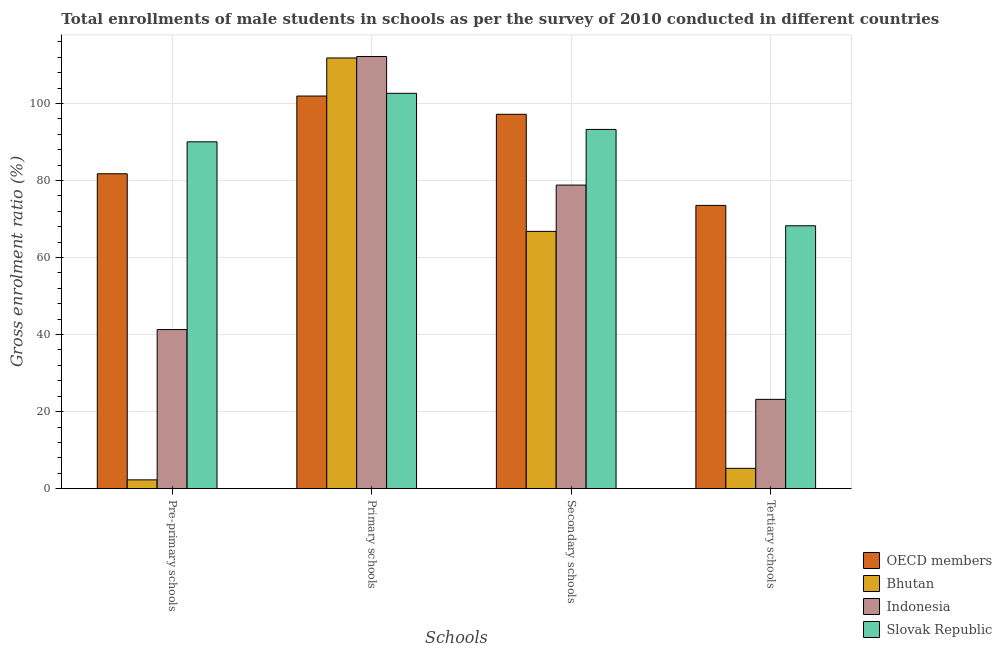Are the number of bars per tick equal to the number of legend labels?
Your answer should be compact. Yes. How many bars are there on the 2nd tick from the right?
Your response must be concise. 4. What is the label of the 3rd group of bars from the left?
Make the answer very short. Secondary schools. What is the gross enrolment ratio(male) in secondary schools in Slovak Republic?
Your answer should be very brief. 93.25. Across all countries, what is the maximum gross enrolment ratio(male) in primary schools?
Offer a very short reply. 112.19. Across all countries, what is the minimum gross enrolment ratio(male) in secondary schools?
Provide a succinct answer. 66.79. In which country was the gross enrolment ratio(male) in pre-primary schools maximum?
Provide a short and direct response. Slovak Republic. In which country was the gross enrolment ratio(male) in tertiary schools minimum?
Your answer should be compact. Bhutan. What is the total gross enrolment ratio(male) in pre-primary schools in the graph?
Offer a very short reply. 215.37. What is the difference between the gross enrolment ratio(male) in pre-primary schools in Bhutan and that in OECD members?
Ensure brevity in your answer.  -79.45. What is the difference between the gross enrolment ratio(male) in tertiary schools in Bhutan and the gross enrolment ratio(male) in pre-primary schools in OECD members?
Your response must be concise. -76.46. What is the average gross enrolment ratio(male) in pre-primary schools per country?
Your response must be concise. 53.84. What is the difference between the gross enrolment ratio(male) in secondary schools and gross enrolment ratio(male) in pre-primary schools in OECD members?
Offer a terse response. 15.44. In how many countries, is the gross enrolment ratio(male) in primary schools greater than 60 %?
Offer a very short reply. 4. What is the ratio of the gross enrolment ratio(male) in secondary schools in Bhutan to that in OECD members?
Your response must be concise. 0.69. Is the gross enrolment ratio(male) in secondary schools in OECD members less than that in Slovak Republic?
Your answer should be very brief. No. What is the difference between the highest and the second highest gross enrolment ratio(male) in primary schools?
Provide a succinct answer. 0.38. What is the difference between the highest and the lowest gross enrolment ratio(male) in tertiary schools?
Make the answer very short. 68.25. What does the 3rd bar from the right in Pre-primary schools represents?
Your answer should be compact. Bhutan. Is it the case that in every country, the sum of the gross enrolment ratio(male) in pre-primary schools and gross enrolment ratio(male) in primary schools is greater than the gross enrolment ratio(male) in secondary schools?
Offer a terse response. Yes. Does the graph contain grids?
Ensure brevity in your answer.  Yes. How many legend labels are there?
Provide a succinct answer. 4. What is the title of the graph?
Offer a very short reply. Total enrollments of male students in schools as per the survey of 2010 conducted in different countries. Does "Nigeria" appear as one of the legend labels in the graph?
Give a very brief answer. No. What is the label or title of the X-axis?
Offer a terse response. Schools. What is the Gross enrolment ratio (%) in OECD members in Pre-primary schools?
Your response must be concise. 81.74. What is the Gross enrolment ratio (%) in Bhutan in Pre-primary schools?
Ensure brevity in your answer.  2.29. What is the Gross enrolment ratio (%) of Indonesia in Pre-primary schools?
Your response must be concise. 41.3. What is the Gross enrolment ratio (%) in Slovak Republic in Pre-primary schools?
Offer a very short reply. 90.04. What is the Gross enrolment ratio (%) in OECD members in Primary schools?
Your answer should be compact. 101.92. What is the Gross enrolment ratio (%) of Bhutan in Primary schools?
Offer a very short reply. 111.8. What is the Gross enrolment ratio (%) of Indonesia in Primary schools?
Give a very brief answer. 112.19. What is the Gross enrolment ratio (%) of Slovak Republic in Primary schools?
Offer a terse response. 102.63. What is the Gross enrolment ratio (%) in OECD members in Secondary schools?
Ensure brevity in your answer.  97.18. What is the Gross enrolment ratio (%) of Bhutan in Secondary schools?
Your answer should be compact. 66.79. What is the Gross enrolment ratio (%) in Indonesia in Secondary schools?
Keep it short and to the point. 78.8. What is the Gross enrolment ratio (%) in Slovak Republic in Secondary schools?
Keep it short and to the point. 93.25. What is the Gross enrolment ratio (%) in OECD members in Tertiary schools?
Offer a very short reply. 73.53. What is the Gross enrolment ratio (%) in Bhutan in Tertiary schools?
Your response must be concise. 5.28. What is the Gross enrolment ratio (%) in Indonesia in Tertiary schools?
Keep it short and to the point. 23.19. What is the Gross enrolment ratio (%) in Slovak Republic in Tertiary schools?
Provide a succinct answer. 68.24. Across all Schools, what is the maximum Gross enrolment ratio (%) of OECD members?
Keep it short and to the point. 101.92. Across all Schools, what is the maximum Gross enrolment ratio (%) of Bhutan?
Ensure brevity in your answer.  111.8. Across all Schools, what is the maximum Gross enrolment ratio (%) in Indonesia?
Ensure brevity in your answer.  112.19. Across all Schools, what is the maximum Gross enrolment ratio (%) in Slovak Republic?
Ensure brevity in your answer.  102.63. Across all Schools, what is the minimum Gross enrolment ratio (%) in OECD members?
Your response must be concise. 73.53. Across all Schools, what is the minimum Gross enrolment ratio (%) in Bhutan?
Your response must be concise. 2.29. Across all Schools, what is the minimum Gross enrolment ratio (%) in Indonesia?
Offer a terse response. 23.19. Across all Schools, what is the minimum Gross enrolment ratio (%) of Slovak Republic?
Keep it short and to the point. 68.24. What is the total Gross enrolment ratio (%) of OECD members in the graph?
Give a very brief answer. 354.37. What is the total Gross enrolment ratio (%) of Bhutan in the graph?
Offer a very short reply. 186.16. What is the total Gross enrolment ratio (%) of Indonesia in the graph?
Provide a short and direct response. 255.48. What is the total Gross enrolment ratio (%) of Slovak Republic in the graph?
Your answer should be compact. 354.15. What is the difference between the Gross enrolment ratio (%) of OECD members in Pre-primary schools and that in Primary schools?
Ensure brevity in your answer.  -20.18. What is the difference between the Gross enrolment ratio (%) of Bhutan in Pre-primary schools and that in Primary schools?
Your answer should be very brief. -109.51. What is the difference between the Gross enrolment ratio (%) of Indonesia in Pre-primary schools and that in Primary schools?
Provide a succinct answer. -70.88. What is the difference between the Gross enrolment ratio (%) in Slovak Republic in Pre-primary schools and that in Primary schools?
Your answer should be very brief. -12.59. What is the difference between the Gross enrolment ratio (%) in OECD members in Pre-primary schools and that in Secondary schools?
Your answer should be very brief. -15.44. What is the difference between the Gross enrolment ratio (%) in Bhutan in Pre-primary schools and that in Secondary schools?
Give a very brief answer. -64.5. What is the difference between the Gross enrolment ratio (%) of Indonesia in Pre-primary schools and that in Secondary schools?
Keep it short and to the point. -37.5. What is the difference between the Gross enrolment ratio (%) of Slovak Republic in Pre-primary schools and that in Secondary schools?
Offer a very short reply. -3.21. What is the difference between the Gross enrolment ratio (%) of OECD members in Pre-primary schools and that in Tertiary schools?
Your answer should be very brief. 8.21. What is the difference between the Gross enrolment ratio (%) of Bhutan in Pre-primary schools and that in Tertiary schools?
Ensure brevity in your answer.  -2.99. What is the difference between the Gross enrolment ratio (%) of Indonesia in Pre-primary schools and that in Tertiary schools?
Make the answer very short. 18.12. What is the difference between the Gross enrolment ratio (%) in Slovak Republic in Pre-primary schools and that in Tertiary schools?
Your response must be concise. 21.79. What is the difference between the Gross enrolment ratio (%) of OECD members in Primary schools and that in Secondary schools?
Offer a very short reply. 4.73. What is the difference between the Gross enrolment ratio (%) in Bhutan in Primary schools and that in Secondary schools?
Offer a very short reply. 45.01. What is the difference between the Gross enrolment ratio (%) of Indonesia in Primary schools and that in Secondary schools?
Ensure brevity in your answer.  33.38. What is the difference between the Gross enrolment ratio (%) of Slovak Republic in Primary schools and that in Secondary schools?
Give a very brief answer. 9.38. What is the difference between the Gross enrolment ratio (%) of OECD members in Primary schools and that in Tertiary schools?
Your answer should be compact. 28.39. What is the difference between the Gross enrolment ratio (%) in Bhutan in Primary schools and that in Tertiary schools?
Offer a terse response. 106.52. What is the difference between the Gross enrolment ratio (%) of Indonesia in Primary schools and that in Tertiary schools?
Your answer should be very brief. 89. What is the difference between the Gross enrolment ratio (%) in Slovak Republic in Primary schools and that in Tertiary schools?
Your answer should be very brief. 34.38. What is the difference between the Gross enrolment ratio (%) of OECD members in Secondary schools and that in Tertiary schools?
Keep it short and to the point. 23.65. What is the difference between the Gross enrolment ratio (%) in Bhutan in Secondary schools and that in Tertiary schools?
Give a very brief answer. 61.51. What is the difference between the Gross enrolment ratio (%) of Indonesia in Secondary schools and that in Tertiary schools?
Ensure brevity in your answer.  55.62. What is the difference between the Gross enrolment ratio (%) of Slovak Republic in Secondary schools and that in Tertiary schools?
Your answer should be very brief. 25.01. What is the difference between the Gross enrolment ratio (%) in OECD members in Pre-primary schools and the Gross enrolment ratio (%) in Bhutan in Primary schools?
Your answer should be very brief. -30.06. What is the difference between the Gross enrolment ratio (%) in OECD members in Pre-primary schools and the Gross enrolment ratio (%) in Indonesia in Primary schools?
Offer a very short reply. -30.45. What is the difference between the Gross enrolment ratio (%) in OECD members in Pre-primary schools and the Gross enrolment ratio (%) in Slovak Republic in Primary schools?
Your answer should be very brief. -20.89. What is the difference between the Gross enrolment ratio (%) in Bhutan in Pre-primary schools and the Gross enrolment ratio (%) in Indonesia in Primary schools?
Your response must be concise. -109.89. What is the difference between the Gross enrolment ratio (%) of Bhutan in Pre-primary schools and the Gross enrolment ratio (%) of Slovak Republic in Primary schools?
Your answer should be very brief. -100.33. What is the difference between the Gross enrolment ratio (%) in Indonesia in Pre-primary schools and the Gross enrolment ratio (%) in Slovak Republic in Primary schools?
Your answer should be compact. -61.32. What is the difference between the Gross enrolment ratio (%) of OECD members in Pre-primary schools and the Gross enrolment ratio (%) of Bhutan in Secondary schools?
Your answer should be compact. 14.95. What is the difference between the Gross enrolment ratio (%) of OECD members in Pre-primary schools and the Gross enrolment ratio (%) of Indonesia in Secondary schools?
Ensure brevity in your answer.  2.93. What is the difference between the Gross enrolment ratio (%) of OECD members in Pre-primary schools and the Gross enrolment ratio (%) of Slovak Republic in Secondary schools?
Offer a terse response. -11.51. What is the difference between the Gross enrolment ratio (%) in Bhutan in Pre-primary schools and the Gross enrolment ratio (%) in Indonesia in Secondary schools?
Give a very brief answer. -76.51. What is the difference between the Gross enrolment ratio (%) of Bhutan in Pre-primary schools and the Gross enrolment ratio (%) of Slovak Republic in Secondary schools?
Your answer should be compact. -90.96. What is the difference between the Gross enrolment ratio (%) of Indonesia in Pre-primary schools and the Gross enrolment ratio (%) of Slovak Republic in Secondary schools?
Make the answer very short. -51.95. What is the difference between the Gross enrolment ratio (%) of OECD members in Pre-primary schools and the Gross enrolment ratio (%) of Bhutan in Tertiary schools?
Provide a short and direct response. 76.46. What is the difference between the Gross enrolment ratio (%) of OECD members in Pre-primary schools and the Gross enrolment ratio (%) of Indonesia in Tertiary schools?
Provide a short and direct response. 58.55. What is the difference between the Gross enrolment ratio (%) of OECD members in Pre-primary schools and the Gross enrolment ratio (%) of Slovak Republic in Tertiary schools?
Offer a terse response. 13.5. What is the difference between the Gross enrolment ratio (%) in Bhutan in Pre-primary schools and the Gross enrolment ratio (%) in Indonesia in Tertiary schools?
Give a very brief answer. -20.9. What is the difference between the Gross enrolment ratio (%) of Bhutan in Pre-primary schools and the Gross enrolment ratio (%) of Slovak Republic in Tertiary schools?
Make the answer very short. -65.95. What is the difference between the Gross enrolment ratio (%) in Indonesia in Pre-primary schools and the Gross enrolment ratio (%) in Slovak Republic in Tertiary schools?
Give a very brief answer. -26.94. What is the difference between the Gross enrolment ratio (%) of OECD members in Primary schools and the Gross enrolment ratio (%) of Bhutan in Secondary schools?
Keep it short and to the point. 35.13. What is the difference between the Gross enrolment ratio (%) of OECD members in Primary schools and the Gross enrolment ratio (%) of Indonesia in Secondary schools?
Your answer should be very brief. 23.11. What is the difference between the Gross enrolment ratio (%) of OECD members in Primary schools and the Gross enrolment ratio (%) of Slovak Republic in Secondary schools?
Offer a terse response. 8.67. What is the difference between the Gross enrolment ratio (%) in Bhutan in Primary schools and the Gross enrolment ratio (%) in Indonesia in Secondary schools?
Provide a succinct answer. 33. What is the difference between the Gross enrolment ratio (%) of Bhutan in Primary schools and the Gross enrolment ratio (%) of Slovak Republic in Secondary schools?
Ensure brevity in your answer.  18.55. What is the difference between the Gross enrolment ratio (%) of Indonesia in Primary schools and the Gross enrolment ratio (%) of Slovak Republic in Secondary schools?
Your response must be concise. 18.94. What is the difference between the Gross enrolment ratio (%) of OECD members in Primary schools and the Gross enrolment ratio (%) of Bhutan in Tertiary schools?
Offer a very short reply. 96.64. What is the difference between the Gross enrolment ratio (%) in OECD members in Primary schools and the Gross enrolment ratio (%) in Indonesia in Tertiary schools?
Offer a very short reply. 78.73. What is the difference between the Gross enrolment ratio (%) in OECD members in Primary schools and the Gross enrolment ratio (%) in Slovak Republic in Tertiary schools?
Offer a very short reply. 33.67. What is the difference between the Gross enrolment ratio (%) in Bhutan in Primary schools and the Gross enrolment ratio (%) in Indonesia in Tertiary schools?
Offer a very short reply. 88.61. What is the difference between the Gross enrolment ratio (%) of Bhutan in Primary schools and the Gross enrolment ratio (%) of Slovak Republic in Tertiary schools?
Offer a very short reply. 43.56. What is the difference between the Gross enrolment ratio (%) of Indonesia in Primary schools and the Gross enrolment ratio (%) of Slovak Republic in Tertiary schools?
Your answer should be compact. 43.94. What is the difference between the Gross enrolment ratio (%) in OECD members in Secondary schools and the Gross enrolment ratio (%) in Bhutan in Tertiary schools?
Your answer should be compact. 91.9. What is the difference between the Gross enrolment ratio (%) in OECD members in Secondary schools and the Gross enrolment ratio (%) in Indonesia in Tertiary schools?
Provide a succinct answer. 73.99. What is the difference between the Gross enrolment ratio (%) of OECD members in Secondary schools and the Gross enrolment ratio (%) of Slovak Republic in Tertiary schools?
Offer a terse response. 28.94. What is the difference between the Gross enrolment ratio (%) in Bhutan in Secondary schools and the Gross enrolment ratio (%) in Indonesia in Tertiary schools?
Provide a short and direct response. 43.6. What is the difference between the Gross enrolment ratio (%) in Bhutan in Secondary schools and the Gross enrolment ratio (%) in Slovak Republic in Tertiary schools?
Keep it short and to the point. -1.45. What is the difference between the Gross enrolment ratio (%) in Indonesia in Secondary schools and the Gross enrolment ratio (%) in Slovak Republic in Tertiary schools?
Offer a terse response. 10.56. What is the average Gross enrolment ratio (%) in OECD members per Schools?
Ensure brevity in your answer.  88.59. What is the average Gross enrolment ratio (%) in Bhutan per Schools?
Provide a short and direct response. 46.54. What is the average Gross enrolment ratio (%) in Indonesia per Schools?
Provide a short and direct response. 63.87. What is the average Gross enrolment ratio (%) of Slovak Republic per Schools?
Your answer should be compact. 88.54. What is the difference between the Gross enrolment ratio (%) of OECD members and Gross enrolment ratio (%) of Bhutan in Pre-primary schools?
Offer a terse response. 79.45. What is the difference between the Gross enrolment ratio (%) in OECD members and Gross enrolment ratio (%) in Indonesia in Pre-primary schools?
Your response must be concise. 40.44. What is the difference between the Gross enrolment ratio (%) of OECD members and Gross enrolment ratio (%) of Slovak Republic in Pre-primary schools?
Make the answer very short. -8.3. What is the difference between the Gross enrolment ratio (%) of Bhutan and Gross enrolment ratio (%) of Indonesia in Pre-primary schools?
Your response must be concise. -39.01. What is the difference between the Gross enrolment ratio (%) of Bhutan and Gross enrolment ratio (%) of Slovak Republic in Pre-primary schools?
Your response must be concise. -87.74. What is the difference between the Gross enrolment ratio (%) in Indonesia and Gross enrolment ratio (%) in Slovak Republic in Pre-primary schools?
Keep it short and to the point. -48.73. What is the difference between the Gross enrolment ratio (%) of OECD members and Gross enrolment ratio (%) of Bhutan in Primary schools?
Keep it short and to the point. -9.89. What is the difference between the Gross enrolment ratio (%) in OECD members and Gross enrolment ratio (%) in Indonesia in Primary schools?
Keep it short and to the point. -10.27. What is the difference between the Gross enrolment ratio (%) in OECD members and Gross enrolment ratio (%) in Slovak Republic in Primary schools?
Your response must be concise. -0.71. What is the difference between the Gross enrolment ratio (%) of Bhutan and Gross enrolment ratio (%) of Indonesia in Primary schools?
Make the answer very short. -0.38. What is the difference between the Gross enrolment ratio (%) in Bhutan and Gross enrolment ratio (%) in Slovak Republic in Primary schools?
Keep it short and to the point. 9.18. What is the difference between the Gross enrolment ratio (%) in Indonesia and Gross enrolment ratio (%) in Slovak Republic in Primary schools?
Ensure brevity in your answer.  9.56. What is the difference between the Gross enrolment ratio (%) in OECD members and Gross enrolment ratio (%) in Bhutan in Secondary schools?
Your answer should be very brief. 30.39. What is the difference between the Gross enrolment ratio (%) in OECD members and Gross enrolment ratio (%) in Indonesia in Secondary schools?
Your answer should be compact. 18.38. What is the difference between the Gross enrolment ratio (%) in OECD members and Gross enrolment ratio (%) in Slovak Republic in Secondary schools?
Provide a short and direct response. 3.93. What is the difference between the Gross enrolment ratio (%) of Bhutan and Gross enrolment ratio (%) of Indonesia in Secondary schools?
Your response must be concise. -12.02. What is the difference between the Gross enrolment ratio (%) of Bhutan and Gross enrolment ratio (%) of Slovak Republic in Secondary schools?
Your answer should be compact. -26.46. What is the difference between the Gross enrolment ratio (%) in Indonesia and Gross enrolment ratio (%) in Slovak Republic in Secondary schools?
Offer a terse response. -14.45. What is the difference between the Gross enrolment ratio (%) in OECD members and Gross enrolment ratio (%) in Bhutan in Tertiary schools?
Provide a short and direct response. 68.25. What is the difference between the Gross enrolment ratio (%) in OECD members and Gross enrolment ratio (%) in Indonesia in Tertiary schools?
Give a very brief answer. 50.34. What is the difference between the Gross enrolment ratio (%) in OECD members and Gross enrolment ratio (%) in Slovak Republic in Tertiary schools?
Ensure brevity in your answer.  5.29. What is the difference between the Gross enrolment ratio (%) in Bhutan and Gross enrolment ratio (%) in Indonesia in Tertiary schools?
Offer a very short reply. -17.91. What is the difference between the Gross enrolment ratio (%) of Bhutan and Gross enrolment ratio (%) of Slovak Republic in Tertiary schools?
Give a very brief answer. -62.96. What is the difference between the Gross enrolment ratio (%) of Indonesia and Gross enrolment ratio (%) of Slovak Republic in Tertiary schools?
Your answer should be compact. -45.05. What is the ratio of the Gross enrolment ratio (%) of OECD members in Pre-primary schools to that in Primary schools?
Provide a succinct answer. 0.8. What is the ratio of the Gross enrolment ratio (%) in Bhutan in Pre-primary schools to that in Primary schools?
Your answer should be very brief. 0.02. What is the ratio of the Gross enrolment ratio (%) of Indonesia in Pre-primary schools to that in Primary schools?
Offer a very short reply. 0.37. What is the ratio of the Gross enrolment ratio (%) in Slovak Republic in Pre-primary schools to that in Primary schools?
Ensure brevity in your answer.  0.88. What is the ratio of the Gross enrolment ratio (%) in OECD members in Pre-primary schools to that in Secondary schools?
Make the answer very short. 0.84. What is the ratio of the Gross enrolment ratio (%) of Bhutan in Pre-primary schools to that in Secondary schools?
Your response must be concise. 0.03. What is the ratio of the Gross enrolment ratio (%) in Indonesia in Pre-primary schools to that in Secondary schools?
Provide a succinct answer. 0.52. What is the ratio of the Gross enrolment ratio (%) in Slovak Republic in Pre-primary schools to that in Secondary schools?
Provide a short and direct response. 0.97. What is the ratio of the Gross enrolment ratio (%) in OECD members in Pre-primary schools to that in Tertiary schools?
Your response must be concise. 1.11. What is the ratio of the Gross enrolment ratio (%) of Bhutan in Pre-primary schools to that in Tertiary schools?
Provide a succinct answer. 0.43. What is the ratio of the Gross enrolment ratio (%) in Indonesia in Pre-primary schools to that in Tertiary schools?
Make the answer very short. 1.78. What is the ratio of the Gross enrolment ratio (%) of Slovak Republic in Pre-primary schools to that in Tertiary schools?
Your answer should be compact. 1.32. What is the ratio of the Gross enrolment ratio (%) of OECD members in Primary schools to that in Secondary schools?
Your response must be concise. 1.05. What is the ratio of the Gross enrolment ratio (%) of Bhutan in Primary schools to that in Secondary schools?
Make the answer very short. 1.67. What is the ratio of the Gross enrolment ratio (%) in Indonesia in Primary schools to that in Secondary schools?
Your answer should be compact. 1.42. What is the ratio of the Gross enrolment ratio (%) in Slovak Republic in Primary schools to that in Secondary schools?
Provide a short and direct response. 1.1. What is the ratio of the Gross enrolment ratio (%) of OECD members in Primary schools to that in Tertiary schools?
Provide a succinct answer. 1.39. What is the ratio of the Gross enrolment ratio (%) in Bhutan in Primary schools to that in Tertiary schools?
Ensure brevity in your answer.  21.17. What is the ratio of the Gross enrolment ratio (%) in Indonesia in Primary schools to that in Tertiary schools?
Offer a terse response. 4.84. What is the ratio of the Gross enrolment ratio (%) of Slovak Republic in Primary schools to that in Tertiary schools?
Give a very brief answer. 1.5. What is the ratio of the Gross enrolment ratio (%) in OECD members in Secondary schools to that in Tertiary schools?
Your response must be concise. 1.32. What is the ratio of the Gross enrolment ratio (%) of Bhutan in Secondary schools to that in Tertiary schools?
Your answer should be very brief. 12.65. What is the ratio of the Gross enrolment ratio (%) of Indonesia in Secondary schools to that in Tertiary schools?
Your answer should be compact. 3.4. What is the ratio of the Gross enrolment ratio (%) in Slovak Republic in Secondary schools to that in Tertiary schools?
Your response must be concise. 1.37. What is the difference between the highest and the second highest Gross enrolment ratio (%) of OECD members?
Offer a very short reply. 4.73. What is the difference between the highest and the second highest Gross enrolment ratio (%) of Bhutan?
Your answer should be very brief. 45.01. What is the difference between the highest and the second highest Gross enrolment ratio (%) of Indonesia?
Ensure brevity in your answer.  33.38. What is the difference between the highest and the second highest Gross enrolment ratio (%) of Slovak Republic?
Your response must be concise. 9.38. What is the difference between the highest and the lowest Gross enrolment ratio (%) of OECD members?
Offer a terse response. 28.39. What is the difference between the highest and the lowest Gross enrolment ratio (%) in Bhutan?
Provide a short and direct response. 109.51. What is the difference between the highest and the lowest Gross enrolment ratio (%) of Indonesia?
Your answer should be very brief. 89. What is the difference between the highest and the lowest Gross enrolment ratio (%) of Slovak Republic?
Your answer should be compact. 34.38. 